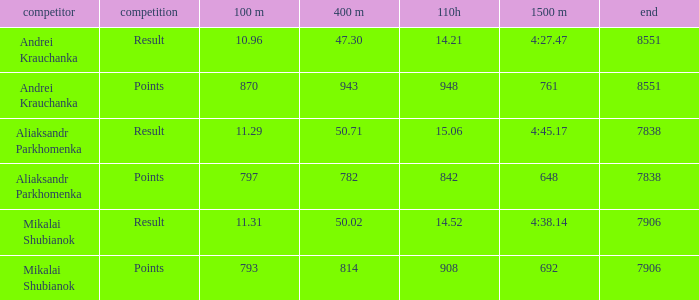What was the final for Mikalai Shubianok who had a 110H less than 908? 7906.0. Help me parse the entirety of this table. {'header': ['competitor', 'competition', '100 m', '400 m', '110h', '1500 m', 'end'], 'rows': [['Andrei Krauchanka', 'Result', '10.96', '47.30', '14.21', '4:27.47', '8551'], ['Andrei Krauchanka', 'Points', '870', '943', '948', '761', '8551'], ['Aliaksandr Parkhomenka', 'Result', '11.29', '50.71', '15.06', '4:45.17', '7838'], ['Aliaksandr Parkhomenka', 'Points', '797', '782', '842', '648', '7838'], ['Mikalai Shubianok', 'Result', '11.31', '50.02', '14.52', '4:38.14', '7906'], ['Mikalai Shubianok', 'Points', '793', '814', '908', '692', '7906']]} 